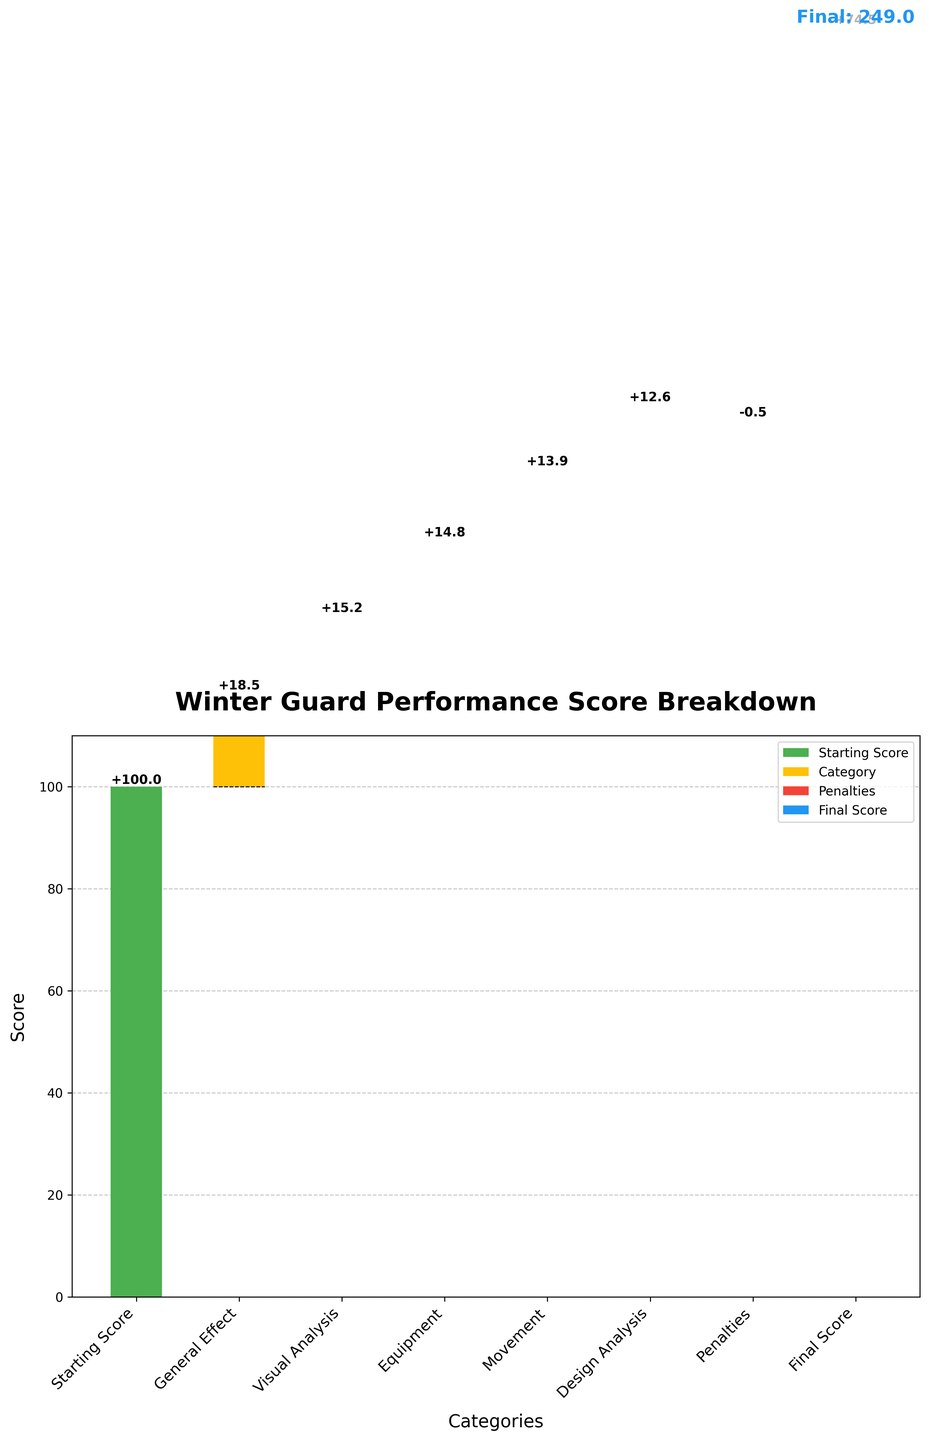What is the title of the chart? The title of the chart is usually displayed at the top, indicating the main subject of the figure. Here, it is "Winter Guard Performance Score Breakdown".
Answer: Winter Guard Performance Score Breakdown Which categories contributed positively to the final score? By looking at the chart, we can see which bars are above the starting point and are not penalties. The categories adding positively are General Effect, Visual Analysis, Equipment, Movement, and Design Analysis.
Answer: General Effect, Visual Analysis, Equipment, Movement, Design Analysis How much did penalties reduce the score? The chart shows a red bar labeled "Penalties" going below the cumulative score. By checking this, we see that the value is -0.5.
Answer: -0.5 What is the final score displayed in the chart? The final score is usually indicated by the last bar in the chart, often labeled explicitly. Here, it is denoted as "Final Score" with a value of 74.5.
Answer: 74.5 What was the score after the 'Movement' category was added? To find this, sum the values from the Starting Score up to and including the Movement category. This involves summing 100 (Starting Score) + 18.5 (General Effect) + 15.2 (Visual Analysis) + 14.8 (Equipment) + 13.9 (Movement).
Answer: 162.4 Which category had the highest positive contribution to the final score? By comparing the heights of the bars related to positive contributions, we see that 'General Effect' has the highest value with 18.5.
Answer: General Effect What is the difference in score contribution between 'Equipment' and 'Design Analysis'? Subtract the value of Design Analysis from Equipment. That is, 14.8 (Equipment) - 12.6 (Design Analysis).
Answer: 2.2 How many categories contribute to increasing the score? Count the number of bars contributing positively. These are General Effect, Visual Analysis, Equipment, Movement, and Design Analysis.
Answer: 5 Is the score improvement from 'Visual Analysis' greater than from 'Movement'? By comparing the values of Visual Analysis (15.2) and Movement (13.9), we can see that Visual Analysis contributes more.
Answer: Yes What are the cumulative scores for each step from the Starting Score to the Final Score? Cumulative scores are the sum of all previous values including the current one. Starting Score: 100, after General Effect: 118.5, after Visual Analysis: 133.7, after Equipment: 148.5, after Movement: 162.4, after Design Analysis: 175, after Penalties: 174.5, Final Score: 74.5.
Answer: 100, 118.5, 133.7, 148.5, 162.4, 175, 174.5, 74.5 